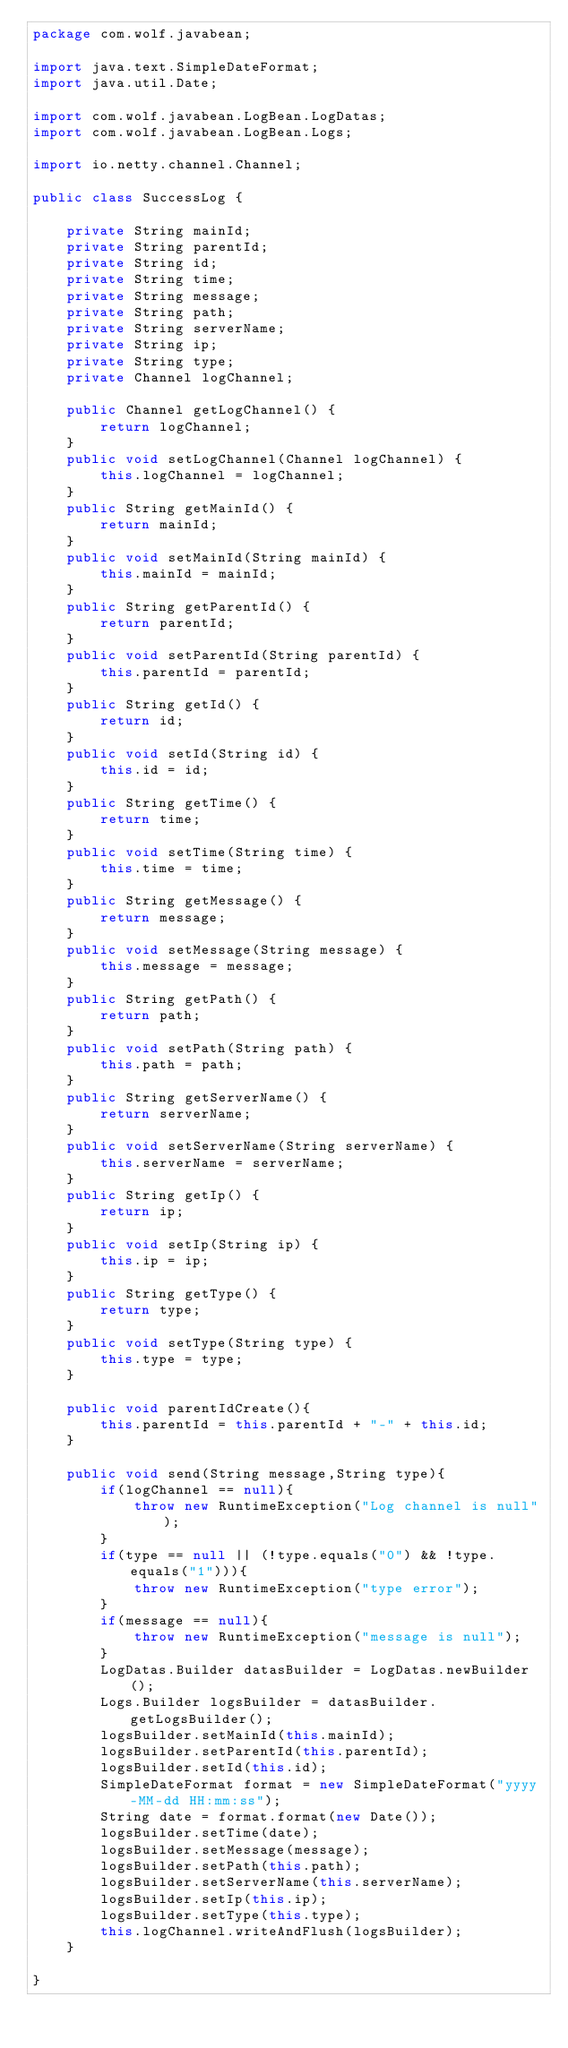Convert code to text. <code><loc_0><loc_0><loc_500><loc_500><_Java_>package com.wolf.javabean;

import java.text.SimpleDateFormat;
import java.util.Date;

import com.wolf.javabean.LogBean.LogDatas;
import com.wolf.javabean.LogBean.Logs;

import io.netty.channel.Channel;

public class SuccessLog {

	private String mainId;
	private String parentId;
	private String id;
	private String time;
	private String message;
	private String path;
	private String serverName;
	private String ip;
	private String type;
	private Channel logChannel;
	
	public Channel getLogChannel() {
		return logChannel;
	}
	public void setLogChannel(Channel logChannel) {
		this.logChannel = logChannel;
	}
	public String getMainId() {
		return mainId;
	}
	public void setMainId(String mainId) {
		this.mainId = mainId;
	}
	public String getParentId() {
		return parentId;
	}
	public void setParentId(String parentId) {
		this.parentId = parentId;
	}
	public String getId() {
		return id;
	}
	public void setId(String id) {
		this.id = id;
	}
	public String getTime() {
		return time;
	}
	public void setTime(String time) {
		this.time = time;
	}
	public String getMessage() {
		return message;
	}
	public void setMessage(String message) {
		this.message = message;
	}
	public String getPath() {
		return path;
	}
	public void setPath(String path) {
		this.path = path;
	}
	public String getServerName() {
		return serverName;
	}
	public void setServerName(String serverName) {
		this.serverName = serverName;
	}
	public String getIp() {
		return ip;
	}
	public void setIp(String ip) {
		this.ip = ip;
	}
	public String getType() {
		return type;
	}
	public void setType(String type) {
		this.type = type;
	}
	
	public void parentIdCreate(){
		this.parentId = this.parentId + "-" + this.id;
	}
	
	public void send(String message,String type){
		if(logChannel == null){
			throw new RuntimeException("Log channel is null");
		}
		if(type == null || (!type.equals("0") && !type.equals("1"))){
			throw new RuntimeException("type error");
		}
		if(message == null){
			throw new RuntimeException("message is null");
		}
		LogDatas.Builder datasBuilder = LogDatas.newBuilder();
		Logs.Builder logsBuilder = datasBuilder.getLogsBuilder();
		logsBuilder.setMainId(this.mainId);
		logsBuilder.setParentId(this.parentId);
		logsBuilder.setId(this.id);
		SimpleDateFormat format = new SimpleDateFormat("yyyy-MM-dd HH:mm:ss");
		String date = format.format(new Date());
		logsBuilder.setTime(date);
		logsBuilder.setMessage(message);
		logsBuilder.setPath(this.path);
		logsBuilder.setServerName(this.serverName);
		logsBuilder.setIp(this.ip);
		logsBuilder.setType(this.type);
		this.logChannel.writeAndFlush(logsBuilder);
	}
	
}
</code> 